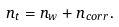<formula> <loc_0><loc_0><loc_500><loc_500>n _ { t } = n _ { w } + n _ { c o r r } .</formula> 